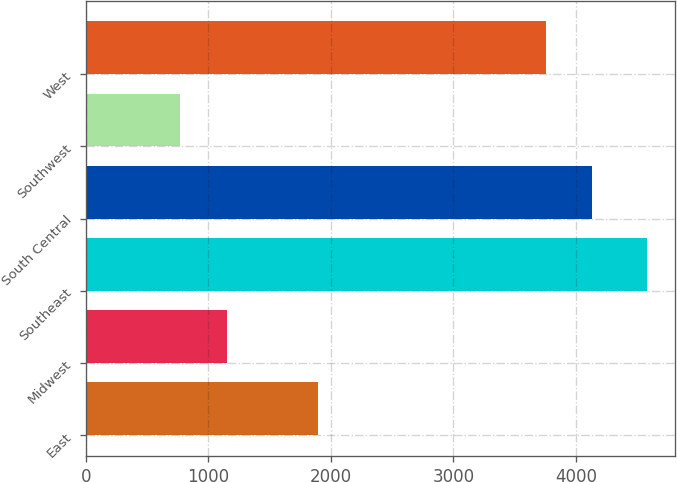<chart> <loc_0><loc_0><loc_500><loc_500><bar_chart><fcel>East<fcel>Midwest<fcel>Southeast<fcel>South Central<fcel>Southwest<fcel>West<nl><fcel>1893.4<fcel>1149.69<fcel>4578.6<fcel>4135.29<fcel>768.7<fcel>3754.3<nl></chart> 